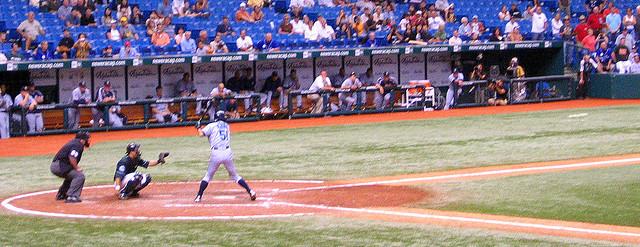Are the players adults?
Quick response, please. Yes. What number is the batter?
Write a very short answer. 51. Is this baseball player swinging a bat?
Quick response, please. Yes. Is the baseball player batting lefty or righty?
Quick response, please. Lefty. 